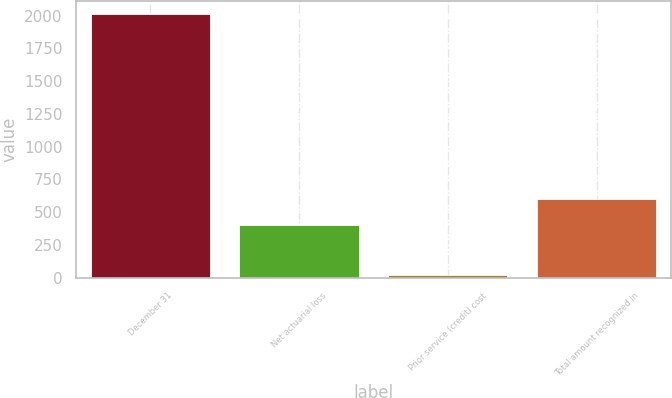Convert chart. <chart><loc_0><loc_0><loc_500><loc_500><bar_chart><fcel>December 31<fcel>Net actuarial loss<fcel>Prior service (credit) cost<fcel>Total amount recognized in<nl><fcel>2012<fcel>401<fcel>21<fcel>600.1<nl></chart> 